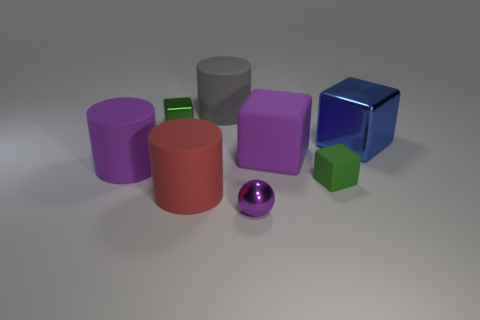Does the purple thing on the left side of the red matte cylinder have the same shape as the small metal thing in front of the small matte object?
Provide a short and direct response. No. There is a green block that is in front of the purple rubber cylinder behind the green object that is in front of the blue cube; what is it made of?
Ensure brevity in your answer.  Rubber. What is the shape of the metal object that is the same size as the gray cylinder?
Your response must be concise. Cube. Are there any blocks of the same color as the tiny matte thing?
Give a very brief answer. Yes. The green rubber thing is what size?
Offer a very short reply. Small. Does the ball have the same material as the blue block?
Provide a succinct answer. Yes. What number of large cylinders are left of the cylinder that is behind the blue metallic block that is behind the purple shiny ball?
Your answer should be very brief. 2. The purple thing in front of the red rubber thing has what shape?
Give a very brief answer. Sphere. How many other things are there of the same material as the red cylinder?
Make the answer very short. 4. Does the small metal cube have the same color as the small matte cube?
Ensure brevity in your answer.  Yes. 